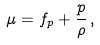<formula> <loc_0><loc_0><loc_500><loc_500>\mu = f _ { p } + \frac { p } { \rho } \, ,</formula> 